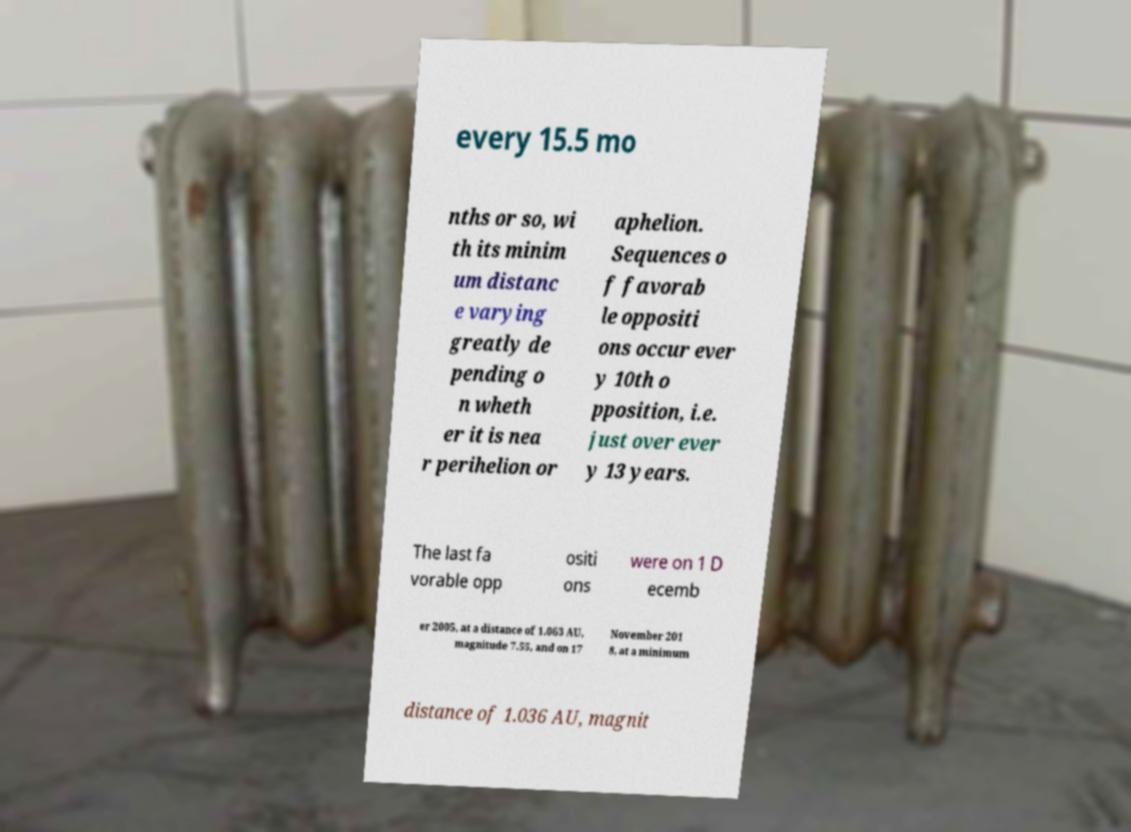There's text embedded in this image that I need extracted. Can you transcribe it verbatim? every 15.5 mo nths or so, wi th its minim um distanc e varying greatly de pending o n wheth er it is nea r perihelion or aphelion. Sequences o f favorab le oppositi ons occur ever y 10th o pposition, i.e. just over ever y 13 years. The last fa vorable opp ositi ons were on 1 D ecemb er 2005, at a distance of 1.063 AU, magnitude 7.55, and on 17 November 201 8, at a minimum distance of 1.036 AU, magnit 